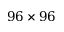Convert formula to latex. <formula><loc_0><loc_0><loc_500><loc_500>9 6 \times 9 6</formula> 